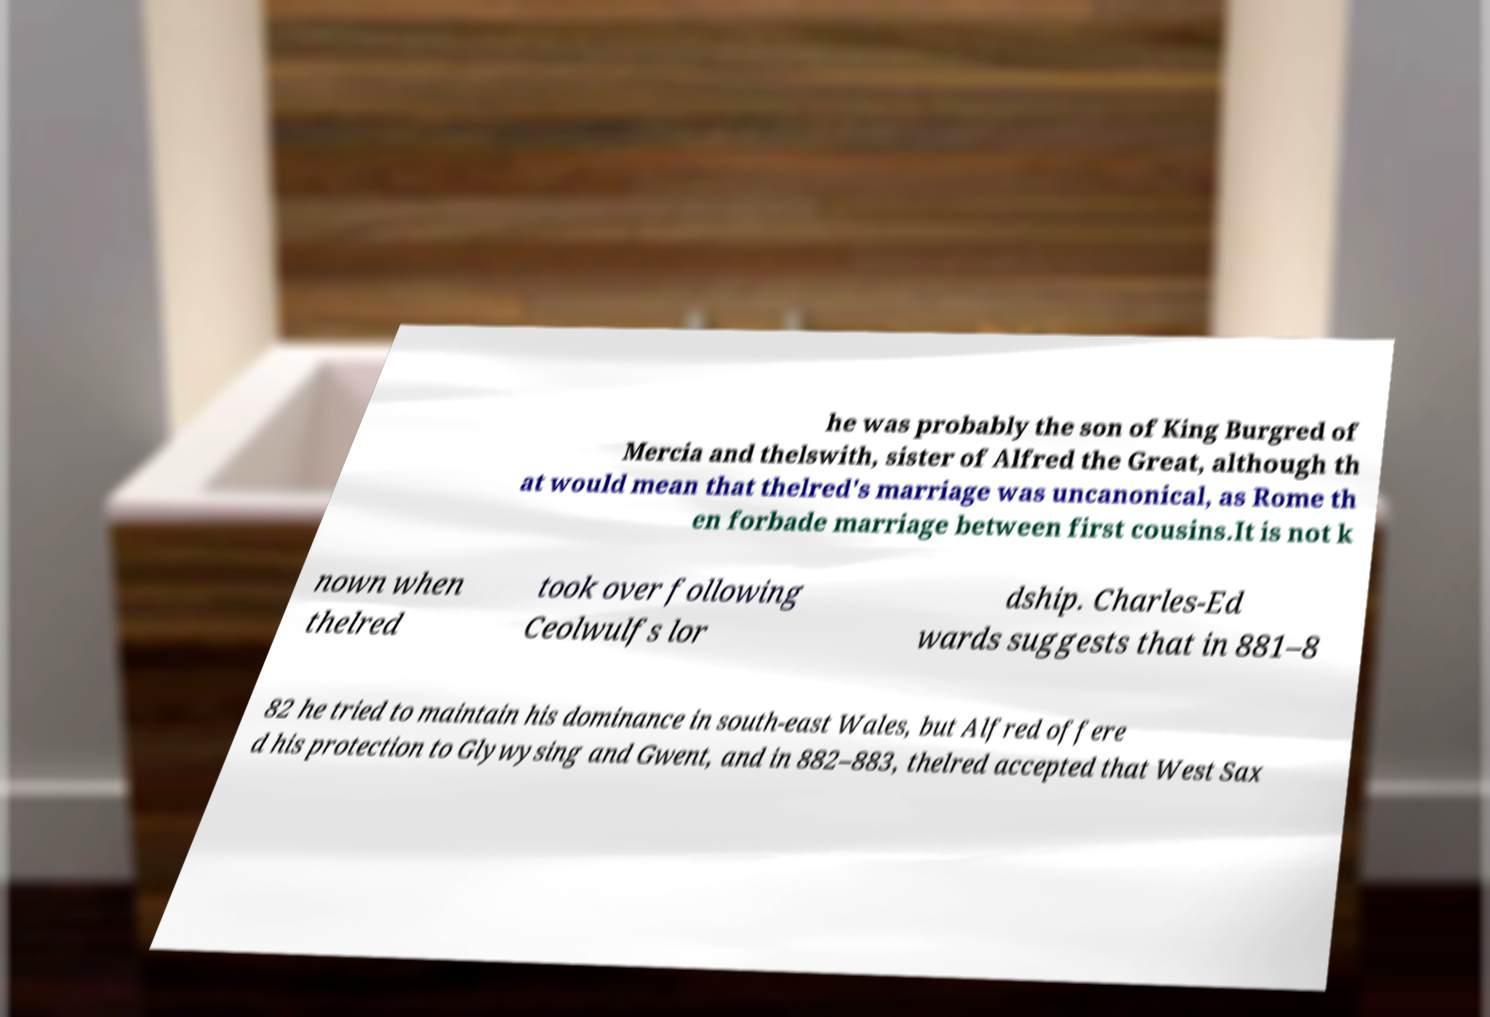Could you extract and type out the text from this image? he was probably the son of King Burgred of Mercia and thelswith, sister of Alfred the Great, although th at would mean that thelred's marriage was uncanonical, as Rome th en forbade marriage between first cousins.It is not k nown when thelred took over following Ceolwulfs lor dship. Charles-Ed wards suggests that in 881–8 82 he tried to maintain his dominance in south-east Wales, but Alfred offere d his protection to Glywysing and Gwent, and in 882–883, thelred accepted that West Sax 